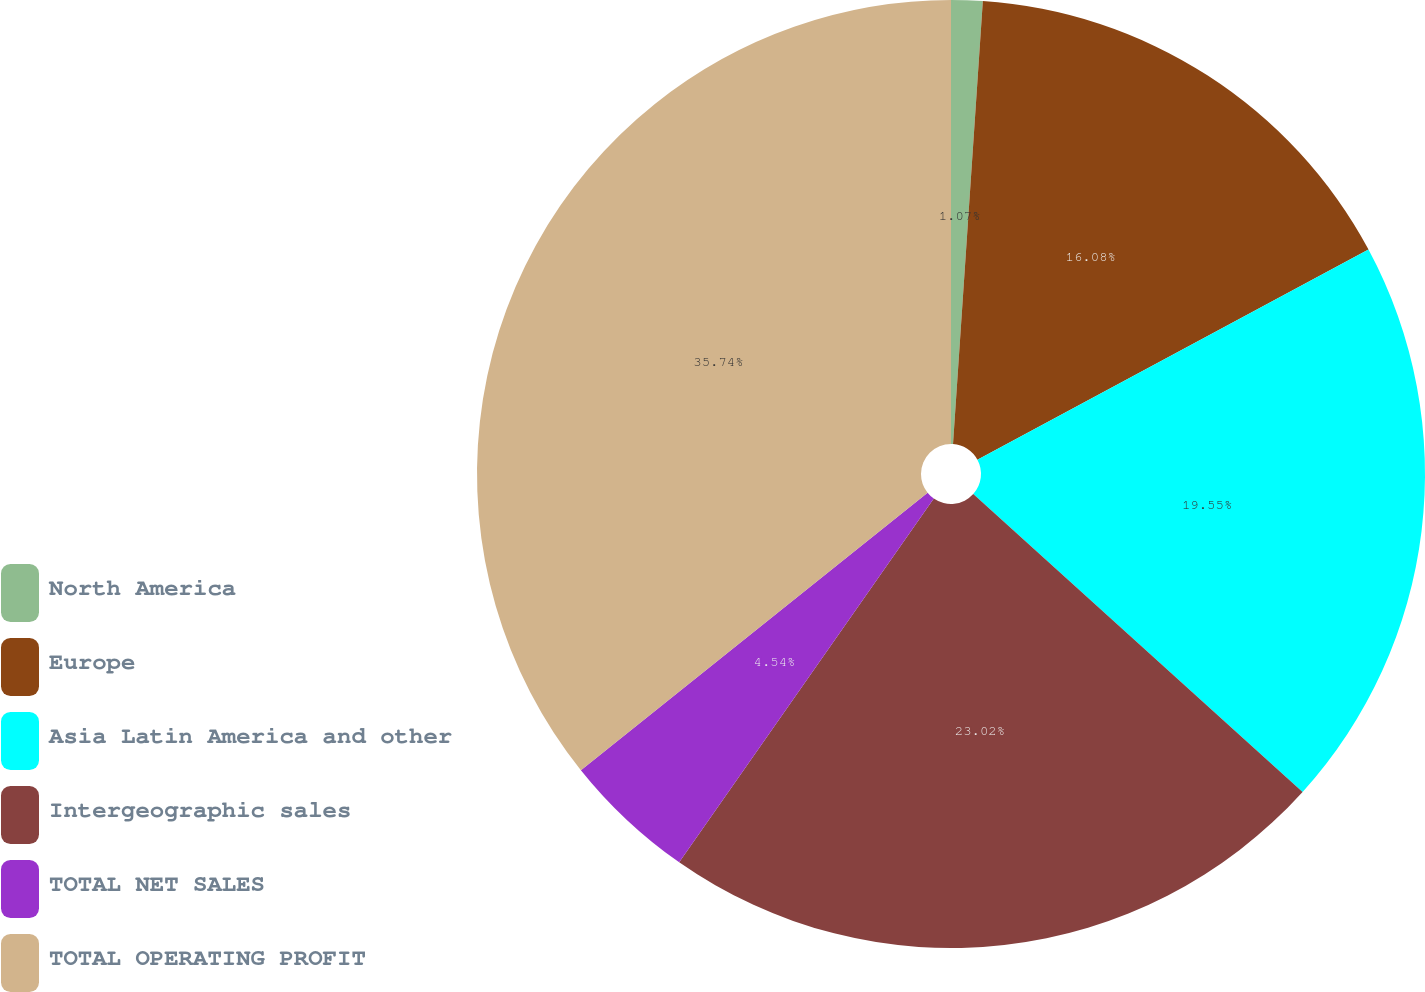Convert chart to OTSL. <chart><loc_0><loc_0><loc_500><loc_500><pie_chart><fcel>North America<fcel>Europe<fcel>Asia Latin America and other<fcel>Intergeographic sales<fcel>TOTAL NET SALES<fcel>TOTAL OPERATING PROFIT<nl><fcel>1.07%<fcel>16.08%<fcel>19.55%<fcel>23.02%<fcel>4.54%<fcel>35.74%<nl></chart> 